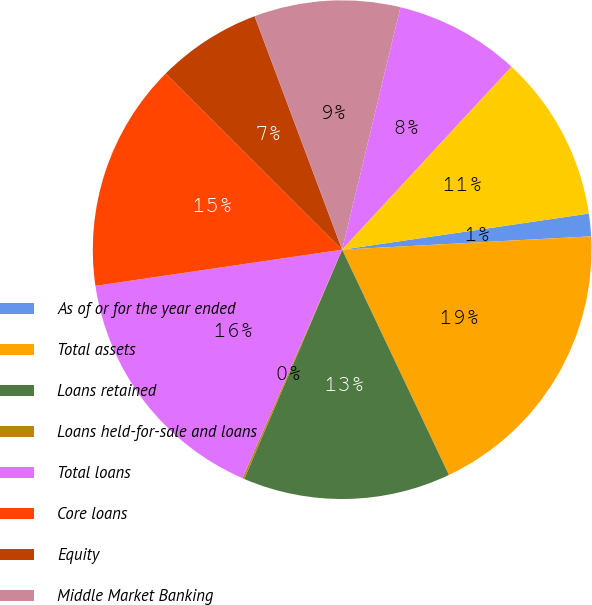Convert chart to OTSL. <chart><loc_0><loc_0><loc_500><loc_500><pie_chart><fcel>As of or for the year ended<fcel>Total assets<fcel>Loans retained<fcel>Loans held-for-sale and loans<fcel>Total loans<fcel>Core loans<fcel>Equity<fcel>Middle Market Banking<fcel>Corporate Client Banking<fcel>Commercial Term Lending<nl><fcel>1.46%<fcel>18.81%<fcel>13.47%<fcel>0.12%<fcel>16.14%<fcel>14.81%<fcel>6.8%<fcel>9.47%<fcel>8.13%<fcel>10.8%<nl></chart> 